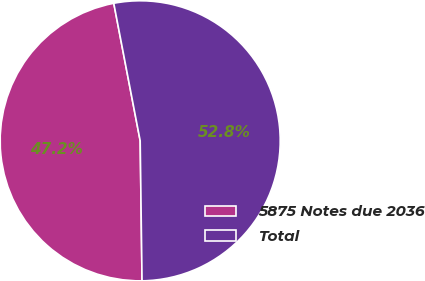Convert chart. <chart><loc_0><loc_0><loc_500><loc_500><pie_chart><fcel>5875 Notes due 2036<fcel>Total<nl><fcel>47.19%<fcel>52.81%<nl></chart> 